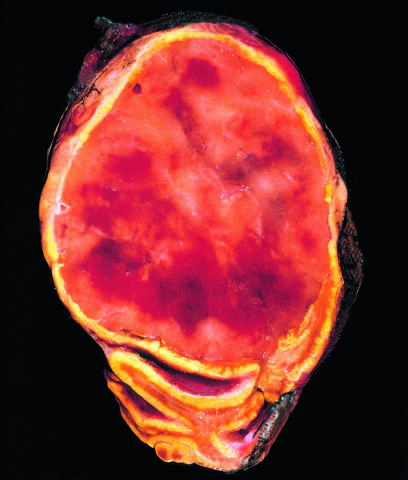re the thickened alveolar walls not visible in this preparation?
Answer the question using a single word or phrase. No 